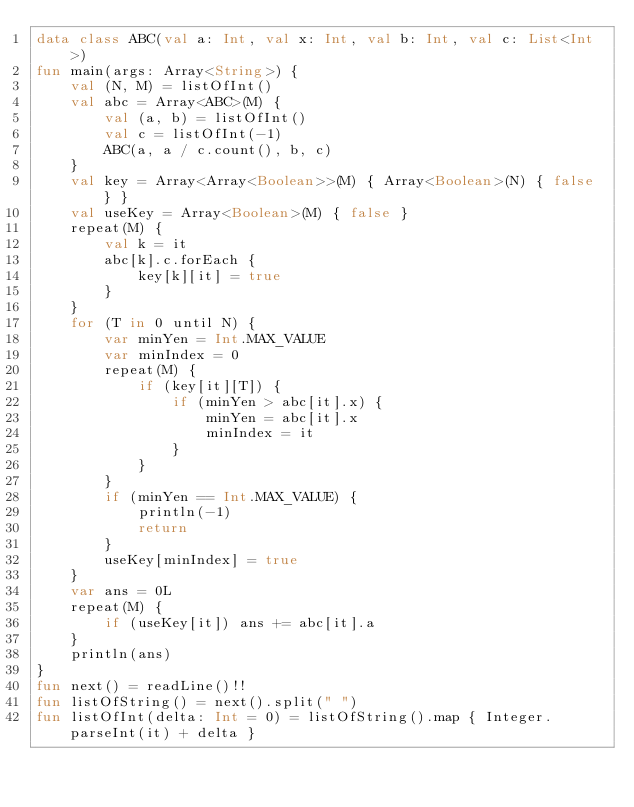<code> <loc_0><loc_0><loc_500><loc_500><_Kotlin_>data class ABC(val a: Int, val x: Int, val b: Int, val c: List<Int>)
fun main(args: Array<String>) {
    val (N, M) = listOfInt()
    val abc = Array<ABC>(M) {
        val (a, b) = listOfInt()
        val c = listOfInt(-1)
        ABC(a, a / c.count(), b, c)
    }
    val key = Array<Array<Boolean>>(M) { Array<Boolean>(N) { false } }
    val useKey = Array<Boolean>(M) { false }
    repeat(M) {
        val k = it
        abc[k].c.forEach {
            key[k][it] = true
        }
    }
    for (T in 0 until N) {
        var minYen = Int.MAX_VALUE
        var minIndex = 0
        repeat(M) {
            if (key[it][T]) {
                if (minYen > abc[it].x) {
                    minYen = abc[it].x
                    minIndex = it
                }
            }
        }
        if (minYen == Int.MAX_VALUE) {
            println(-1)
            return
        }
        useKey[minIndex] = true
    }
    var ans = 0L
    repeat(M) {
        if (useKey[it]) ans += abc[it].a
    }
    println(ans)
}
fun next() = readLine()!!
fun listOfString() = next().split(" ")
fun listOfInt(delta: Int = 0) = listOfString().map { Integer.parseInt(it) + delta }</code> 